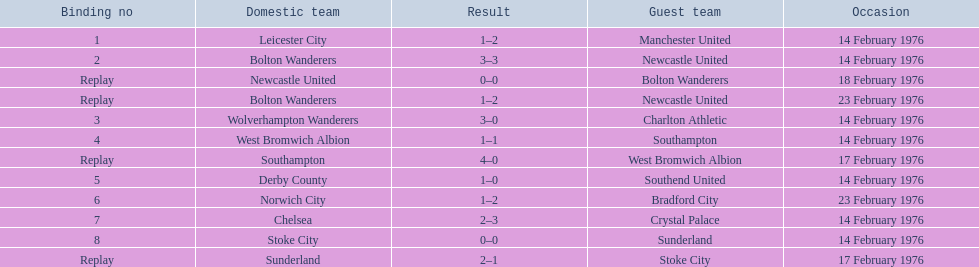Who were all the teams that played? Leicester City, Manchester United, Bolton Wanderers, Newcastle United, Newcastle United, Bolton Wanderers, Bolton Wanderers, Newcastle United, Wolverhampton Wanderers, Charlton Athletic, West Bromwich Albion, Southampton, Southampton, West Bromwich Albion, Derby County, Southend United, Norwich City, Bradford City, Chelsea, Crystal Palace, Stoke City, Sunderland, Sunderland, Stoke City. Which of these teams won? Manchester United, Newcastle United, Wolverhampton Wanderers, Southampton, Derby County, Bradford City, Crystal Palace, Sunderland. What was manchester united's winning score? 1–2. What was the wolverhampton wonders winning score? 3–0. Which of these two teams had the better winning score? Wolverhampton Wanderers. 